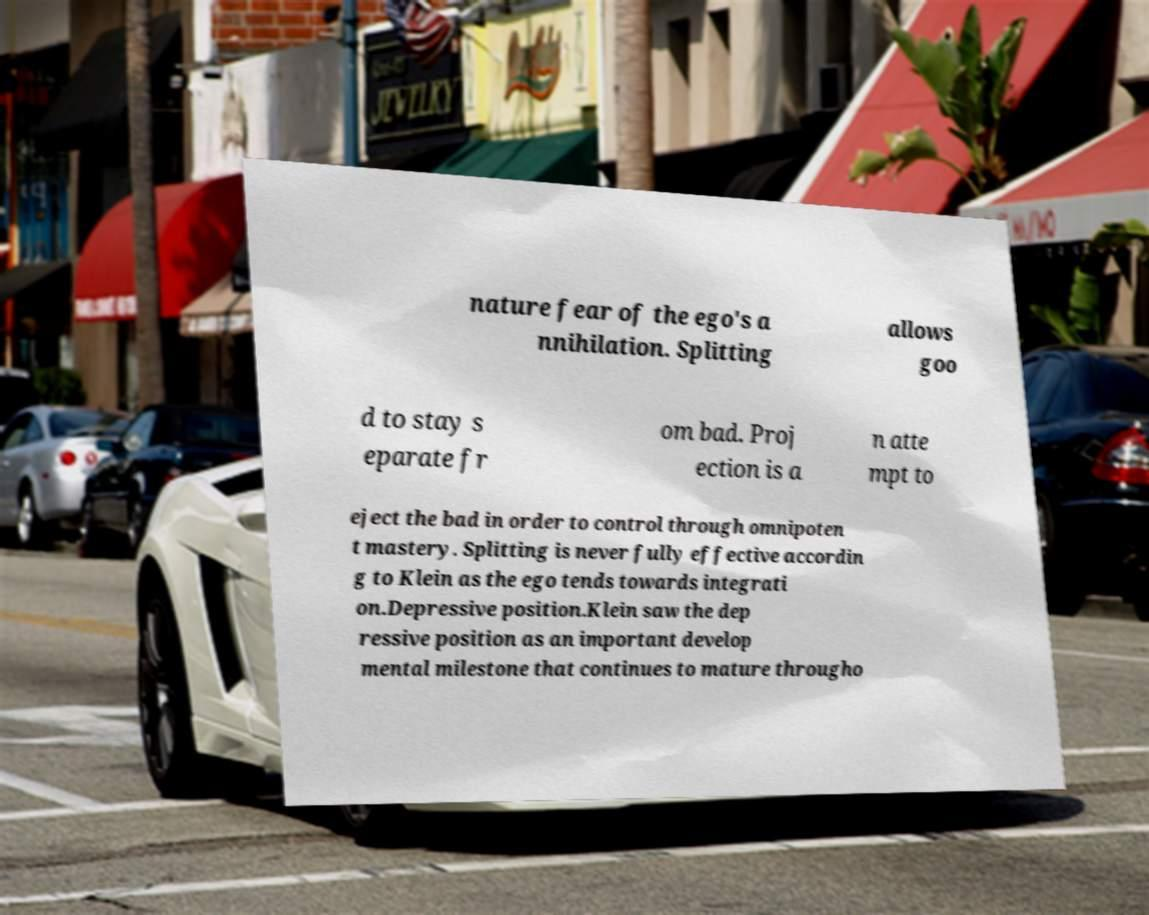Please identify and transcribe the text found in this image. nature fear of the ego's a nnihilation. Splitting allows goo d to stay s eparate fr om bad. Proj ection is a n atte mpt to eject the bad in order to control through omnipoten t mastery. Splitting is never fully effective accordin g to Klein as the ego tends towards integrati on.Depressive position.Klein saw the dep ressive position as an important develop mental milestone that continues to mature througho 